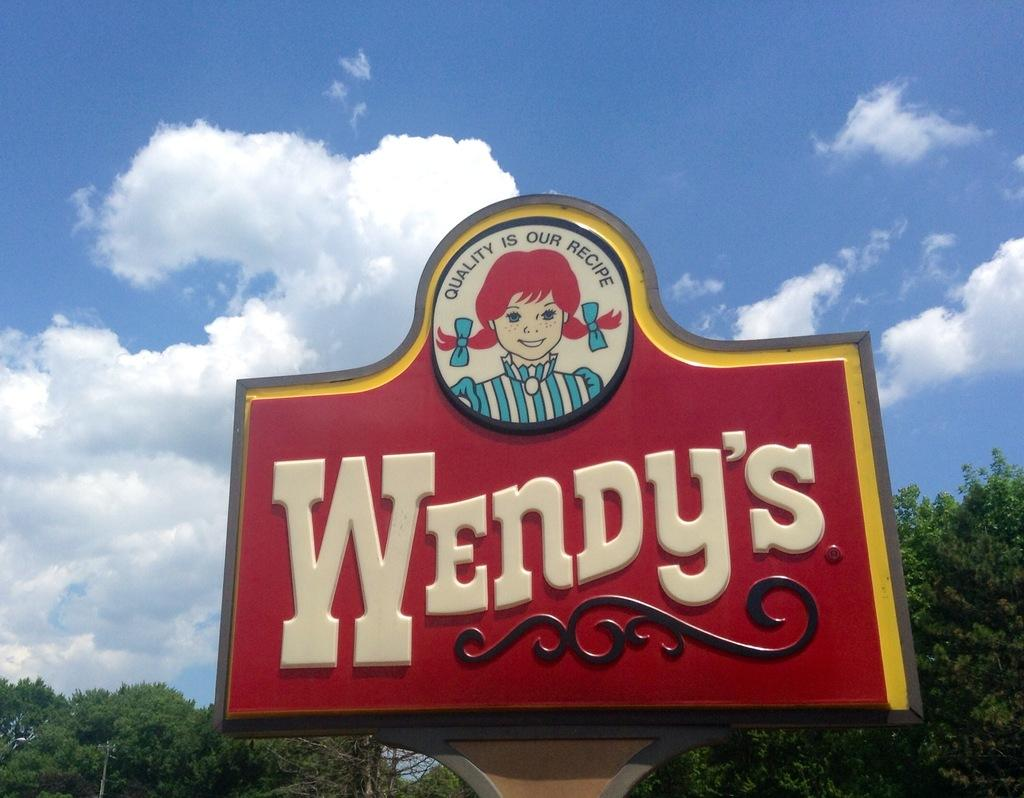What is the main object in the center of the image? There is a board in the center of the image. What is depicted on the board? There is a cartoon of a girl on the board. What else can be seen on the board? There is text on the board. What type of natural elements are visible at the bottom of the image? There are trees at the bottom of the image. What is visible in the sky at the top of the image? There is a sky with clouds at the top of the image. Where is the pancake being stored on the shelf in the image? There is no pancake or shelf present in the image. Can you tell me how many bats are flying in the sky in the image? There are no bats visible in the sky in the image. 